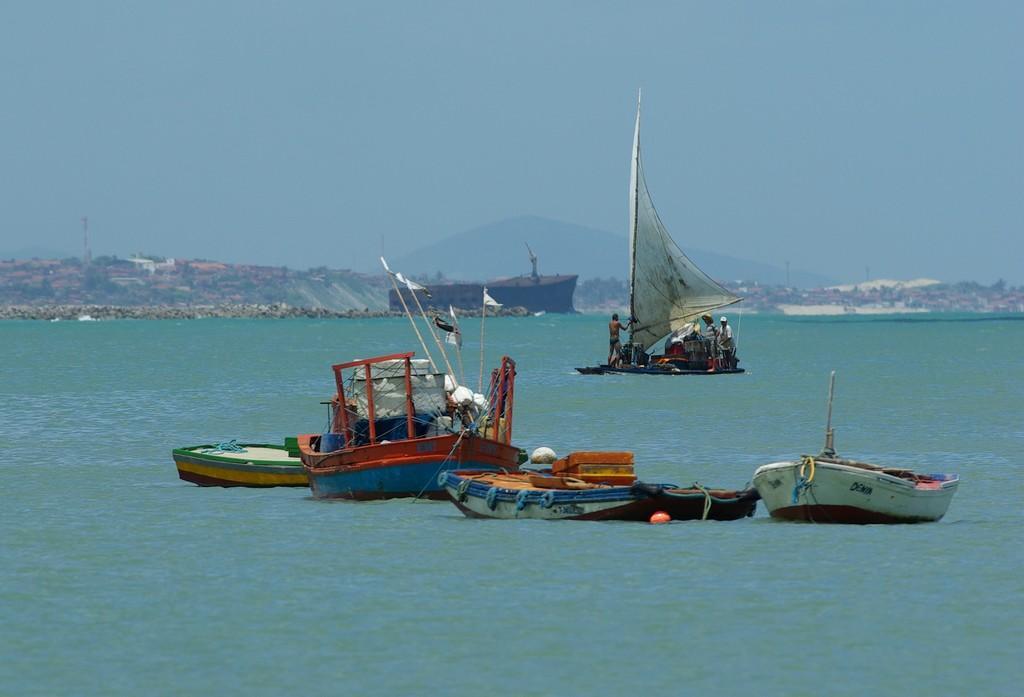Describe this image in one or two sentences. In this image at the bottom there is a river, in that river there are some boats and in the center there is one boat. In that boat there are some persons and in the background there is another boat and some houses, trees and mountains. On the top of the image there is sky. 